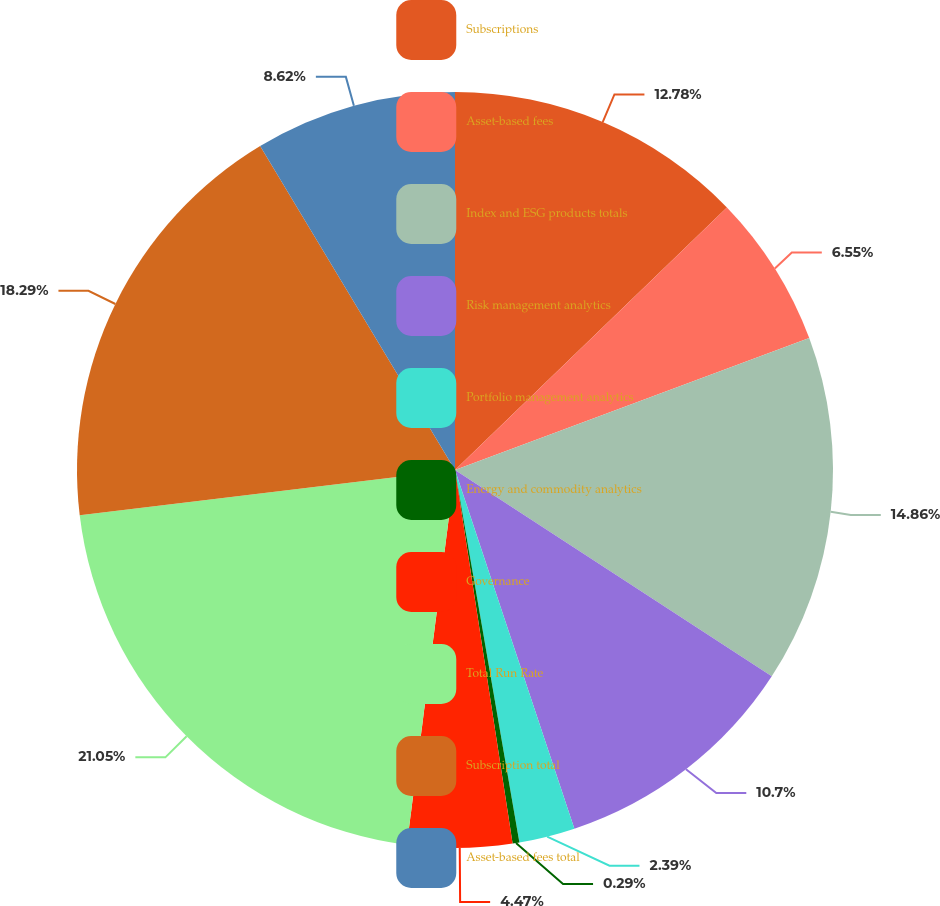Convert chart to OTSL. <chart><loc_0><loc_0><loc_500><loc_500><pie_chart><fcel>Subscriptions<fcel>Asset-based fees<fcel>Index and ESG products totals<fcel>Risk management analytics<fcel>Portfolio management analytics<fcel>Energy and commodity analytics<fcel>Governance<fcel>Total Run Rate<fcel>Subscription total<fcel>Asset-based fees total<nl><fcel>12.78%<fcel>6.55%<fcel>14.86%<fcel>10.7%<fcel>2.39%<fcel>0.29%<fcel>4.47%<fcel>21.06%<fcel>18.29%<fcel>8.62%<nl></chart> 